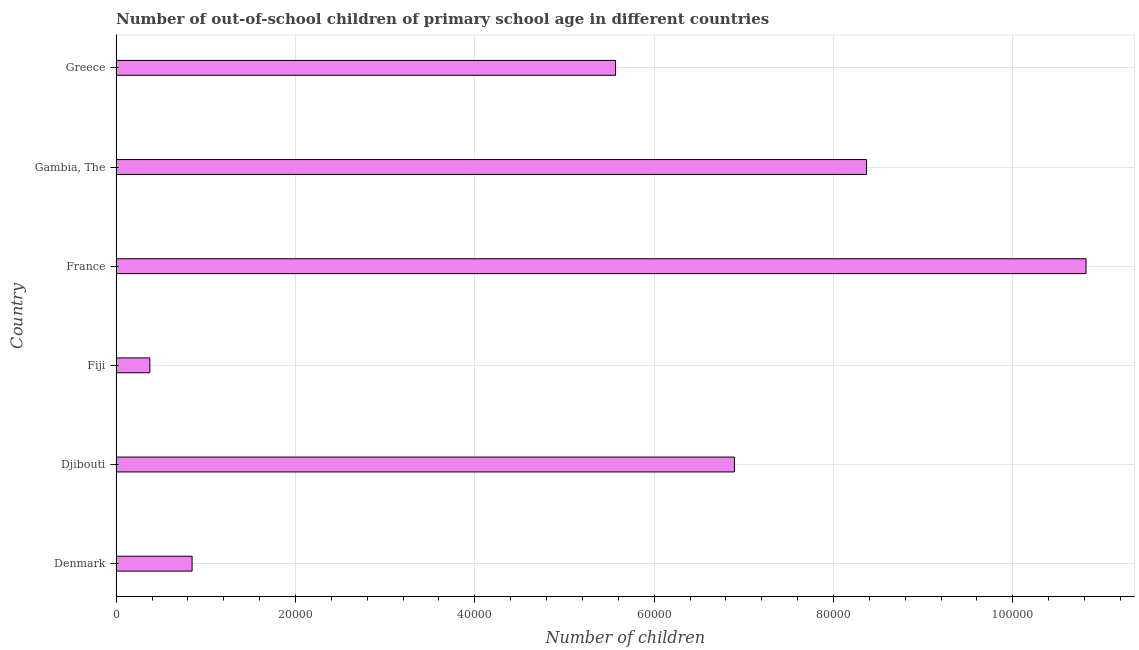What is the title of the graph?
Your answer should be very brief. Number of out-of-school children of primary school age in different countries. What is the label or title of the X-axis?
Keep it short and to the point. Number of children. What is the number of out-of-school children in Greece?
Offer a very short reply. 5.57e+04. Across all countries, what is the maximum number of out-of-school children?
Your answer should be very brief. 1.08e+05. Across all countries, what is the minimum number of out-of-school children?
Ensure brevity in your answer.  3762. In which country was the number of out-of-school children minimum?
Make the answer very short. Fiji. What is the sum of the number of out-of-school children?
Ensure brevity in your answer.  3.29e+05. What is the difference between the number of out-of-school children in Fiji and Greece?
Offer a very short reply. -5.19e+04. What is the average number of out-of-school children per country?
Keep it short and to the point. 5.48e+04. What is the median number of out-of-school children?
Make the answer very short. 6.23e+04. What is the ratio of the number of out-of-school children in Djibouti to that in France?
Offer a very short reply. 0.64. Is the difference between the number of out-of-school children in Djibouti and France greater than the difference between any two countries?
Your answer should be compact. No. What is the difference between the highest and the second highest number of out-of-school children?
Make the answer very short. 2.45e+04. What is the difference between the highest and the lowest number of out-of-school children?
Offer a terse response. 1.04e+05. In how many countries, is the number of out-of-school children greater than the average number of out-of-school children taken over all countries?
Make the answer very short. 4. How many bars are there?
Offer a very short reply. 6. How many countries are there in the graph?
Ensure brevity in your answer.  6. What is the Number of children of Denmark?
Give a very brief answer. 8471. What is the Number of children of Djibouti?
Offer a very short reply. 6.90e+04. What is the Number of children in Fiji?
Your answer should be compact. 3762. What is the Number of children of France?
Your answer should be compact. 1.08e+05. What is the Number of children in Gambia, The?
Your response must be concise. 8.37e+04. What is the Number of children of Greece?
Ensure brevity in your answer.  5.57e+04. What is the difference between the Number of children in Denmark and Djibouti?
Your answer should be very brief. -6.05e+04. What is the difference between the Number of children in Denmark and Fiji?
Keep it short and to the point. 4709. What is the difference between the Number of children in Denmark and France?
Ensure brevity in your answer.  -9.97e+04. What is the difference between the Number of children in Denmark and Gambia, The?
Offer a terse response. -7.52e+04. What is the difference between the Number of children in Denmark and Greece?
Offer a very short reply. -4.72e+04. What is the difference between the Number of children in Djibouti and Fiji?
Your response must be concise. 6.52e+04. What is the difference between the Number of children in Djibouti and France?
Give a very brief answer. -3.92e+04. What is the difference between the Number of children in Djibouti and Gambia, The?
Your answer should be very brief. -1.47e+04. What is the difference between the Number of children in Djibouti and Greece?
Make the answer very short. 1.33e+04. What is the difference between the Number of children in Fiji and France?
Give a very brief answer. -1.04e+05. What is the difference between the Number of children in Fiji and Gambia, The?
Ensure brevity in your answer.  -7.99e+04. What is the difference between the Number of children in Fiji and Greece?
Offer a terse response. -5.19e+04. What is the difference between the Number of children in France and Gambia, The?
Give a very brief answer. 2.45e+04. What is the difference between the Number of children in France and Greece?
Keep it short and to the point. 5.25e+04. What is the difference between the Number of children in Gambia, The and Greece?
Keep it short and to the point. 2.80e+04. What is the ratio of the Number of children in Denmark to that in Djibouti?
Make the answer very short. 0.12. What is the ratio of the Number of children in Denmark to that in Fiji?
Offer a very short reply. 2.25. What is the ratio of the Number of children in Denmark to that in France?
Provide a short and direct response. 0.08. What is the ratio of the Number of children in Denmark to that in Gambia, The?
Offer a very short reply. 0.1. What is the ratio of the Number of children in Denmark to that in Greece?
Your answer should be very brief. 0.15. What is the ratio of the Number of children in Djibouti to that in Fiji?
Offer a very short reply. 18.33. What is the ratio of the Number of children in Djibouti to that in France?
Make the answer very short. 0.64. What is the ratio of the Number of children in Djibouti to that in Gambia, The?
Ensure brevity in your answer.  0.82. What is the ratio of the Number of children in Djibouti to that in Greece?
Make the answer very short. 1.24. What is the ratio of the Number of children in Fiji to that in France?
Provide a succinct answer. 0.04. What is the ratio of the Number of children in Fiji to that in Gambia, The?
Offer a terse response. 0.04. What is the ratio of the Number of children in Fiji to that in Greece?
Provide a succinct answer. 0.07. What is the ratio of the Number of children in France to that in Gambia, The?
Offer a terse response. 1.29. What is the ratio of the Number of children in France to that in Greece?
Offer a terse response. 1.94. What is the ratio of the Number of children in Gambia, The to that in Greece?
Your response must be concise. 1.5. 